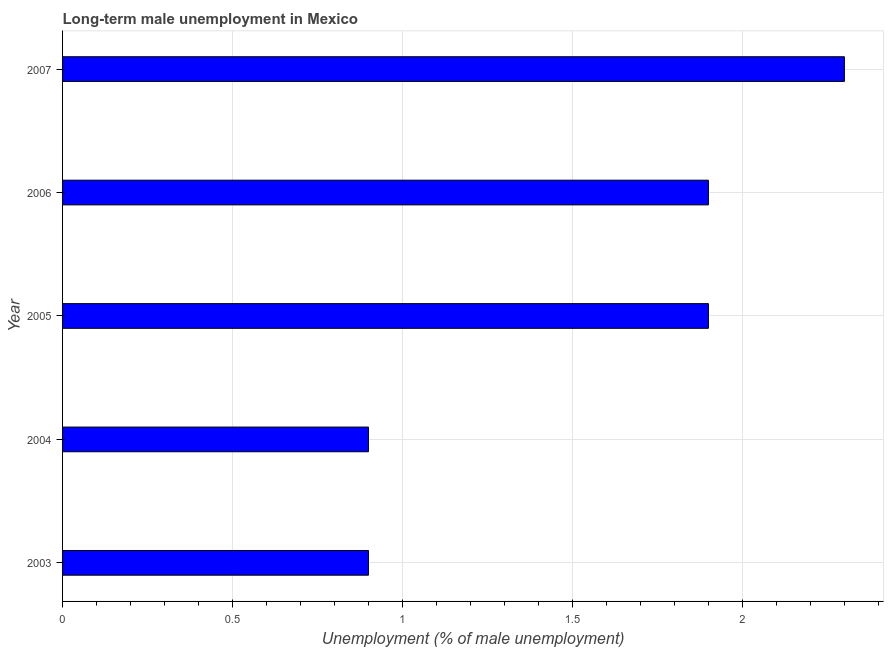Does the graph contain any zero values?
Your response must be concise. No. Does the graph contain grids?
Keep it short and to the point. Yes. What is the title of the graph?
Your answer should be very brief. Long-term male unemployment in Mexico. What is the label or title of the X-axis?
Your response must be concise. Unemployment (% of male unemployment). What is the label or title of the Y-axis?
Make the answer very short. Year. What is the long-term male unemployment in 2005?
Make the answer very short. 1.9. Across all years, what is the maximum long-term male unemployment?
Your answer should be compact. 2.3. Across all years, what is the minimum long-term male unemployment?
Your answer should be very brief. 0.9. What is the sum of the long-term male unemployment?
Make the answer very short. 7.9. What is the difference between the long-term male unemployment in 2004 and 2006?
Make the answer very short. -1. What is the average long-term male unemployment per year?
Your response must be concise. 1.58. What is the median long-term male unemployment?
Your answer should be very brief. 1.9. In how many years, is the long-term male unemployment greater than 1.6 %?
Keep it short and to the point. 3. What is the ratio of the long-term male unemployment in 2005 to that in 2006?
Keep it short and to the point. 1. Is the sum of the long-term male unemployment in 2006 and 2007 greater than the maximum long-term male unemployment across all years?
Offer a terse response. Yes. What is the difference between the highest and the lowest long-term male unemployment?
Ensure brevity in your answer.  1.4. Are all the bars in the graph horizontal?
Give a very brief answer. Yes. How many years are there in the graph?
Ensure brevity in your answer.  5. Are the values on the major ticks of X-axis written in scientific E-notation?
Give a very brief answer. No. What is the Unemployment (% of male unemployment) of 2003?
Give a very brief answer. 0.9. What is the Unemployment (% of male unemployment) in 2004?
Your answer should be very brief. 0.9. What is the Unemployment (% of male unemployment) of 2005?
Ensure brevity in your answer.  1.9. What is the Unemployment (% of male unemployment) of 2006?
Give a very brief answer. 1.9. What is the Unemployment (% of male unemployment) of 2007?
Your answer should be compact. 2.3. What is the difference between the Unemployment (% of male unemployment) in 2003 and 2004?
Keep it short and to the point. 0. What is the difference between the Unemployment (% of male unemployment) in 2004 and 2006?
Offer a terse response. -1. What is the difference between the Unemployment (% of male unemployment) in 2004 and 2007?
Your answer should be compact. -1.4. What is the difference between the Unemployment (% of male unemployment) in 2005 and 2006?
Offer a terse response. 0. What is the difference between the Unemployment (% of male unemployment) in 2005 and 2007?
Offer a very short reply. -0.4. What is the ratio of the Unemployment (% of male unemployment) in 2003 to that in 2005?
Offer a terse response. 0.47. What is the ratio of the Unemployment (% of male unemployment) in 2003 to that in 2006?
Provide a succinct answer. 0.47. What is the ratio of the Unemployment (% of male unemployment) in 2003 to that in 2007?
Provide a short and direct response. 0.39. What is the ratio of the Unemployment (% of male unemployment) in 2004 to that in 2005?
Your answer should be very brief. 0.47. What is the ratio of the Unemployment (% of male unemployment) in 2004 to that in 2006?
Keep it short and to the point. 0.47. What is the ratio of the Unemployment (% of male unemployment) in 2004 to that in 2007?
Offer a very short reply. 0.39. What is the ratio of the Unemployment (% of male unemployment) in 2005 to that in 2007?
Offer a very short reply. 0.83. What is the ratio of the Unemployment (% of male unemployment) in 2006 to that in 2007?
Offer a very short reply. 0.83. 